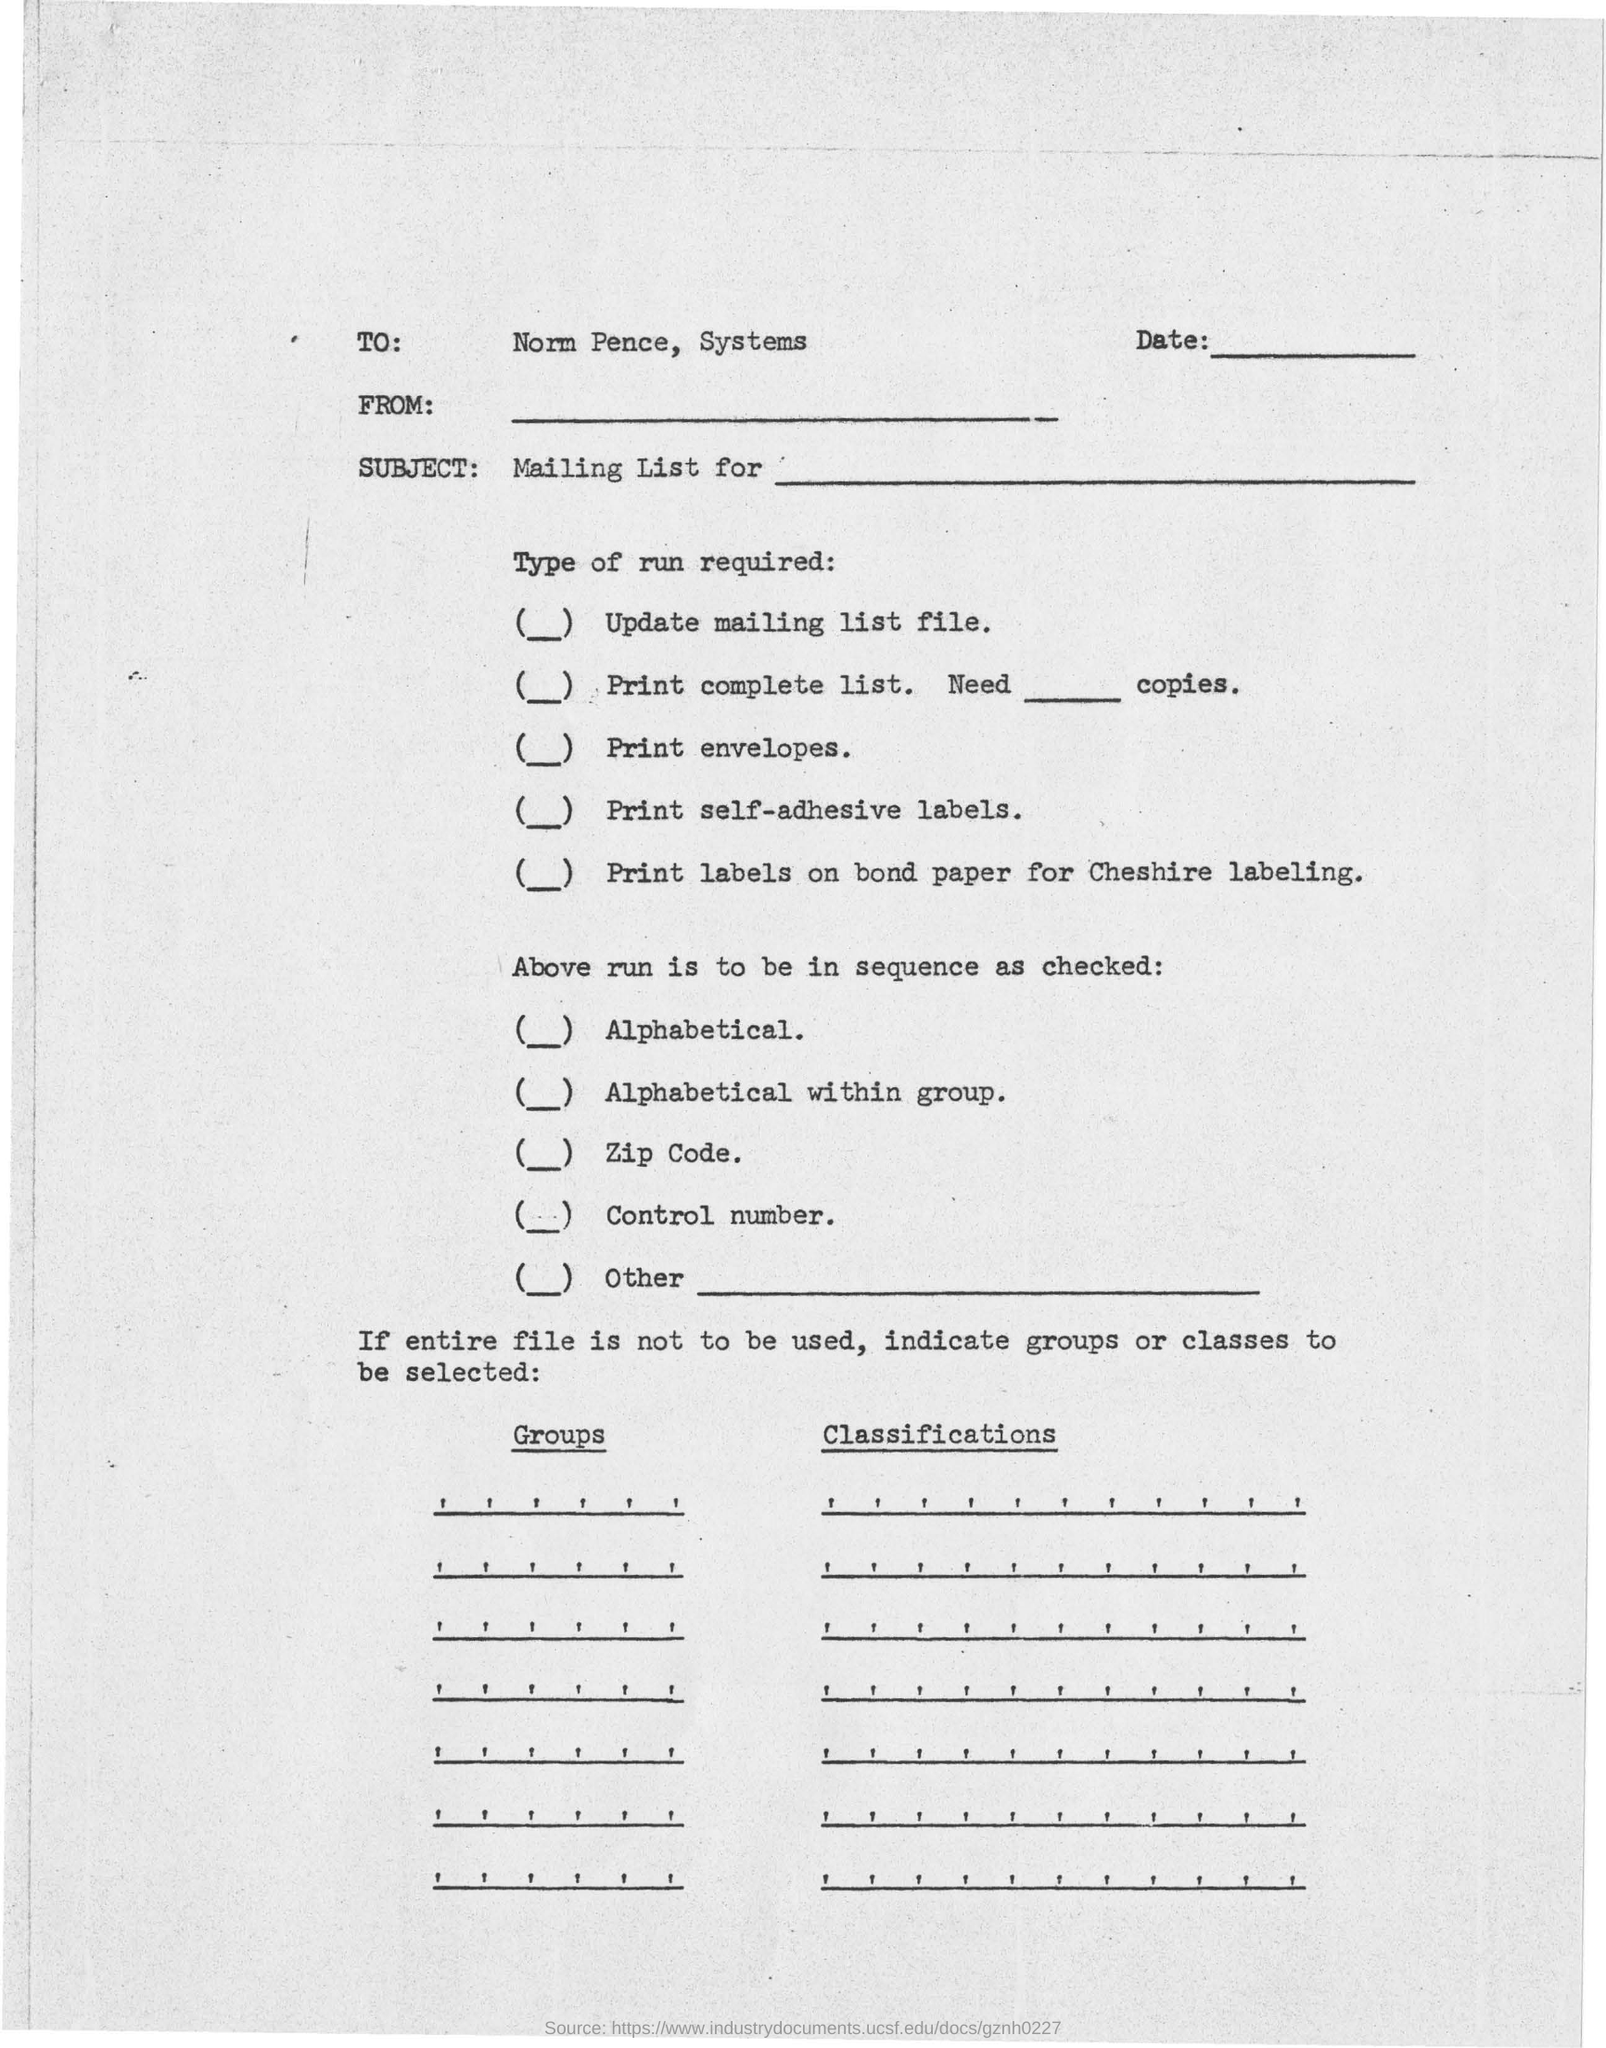Who is the TO mentioned?
Your answer should be very brief. Norm Pence, Systems. 